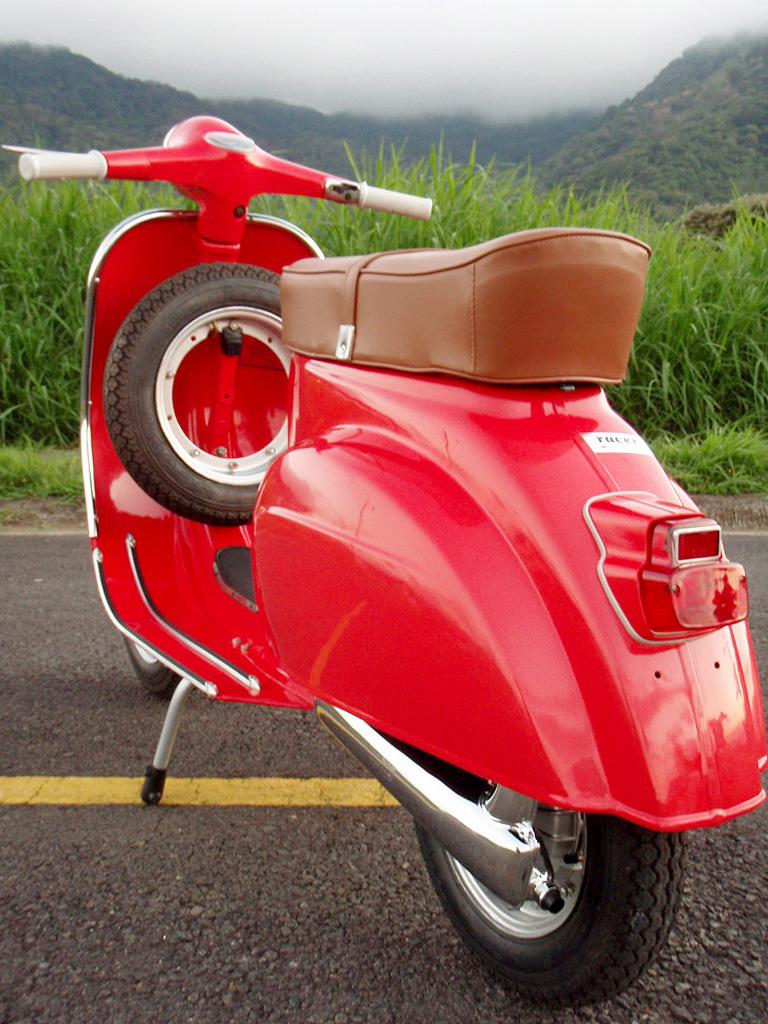What type of vehicle is in the image? There is a red scooter in the image. Where is the scooter located? The scooter is on the road. What additional item can be seen near the scooter? There is a spare tire in the image. What can be seen on the hills in the background? Grass and trees are visible on the hills. What atmospheric condition is present in the image? Fog is visible in the image. Can you tell me what receipt the cook is holding while riding the carriage in the image? There is no carriage, cook, or receipt present in the image. 